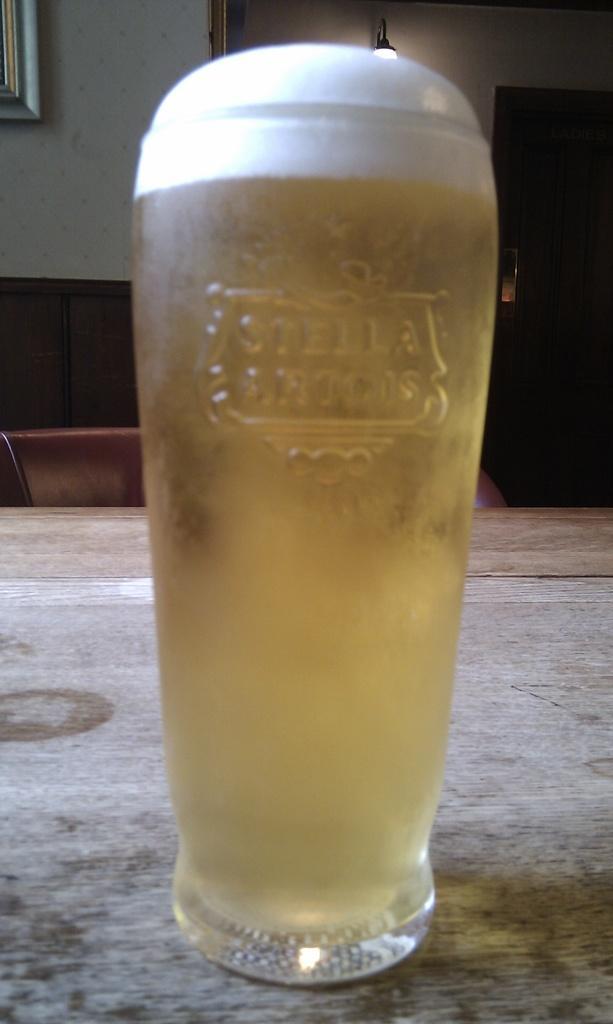Can you describe this image briefly? In this picture there is a wooden table, on the table there is beer filled in glass. In the background there are chairs, closet, frame, wall and a lamp. 